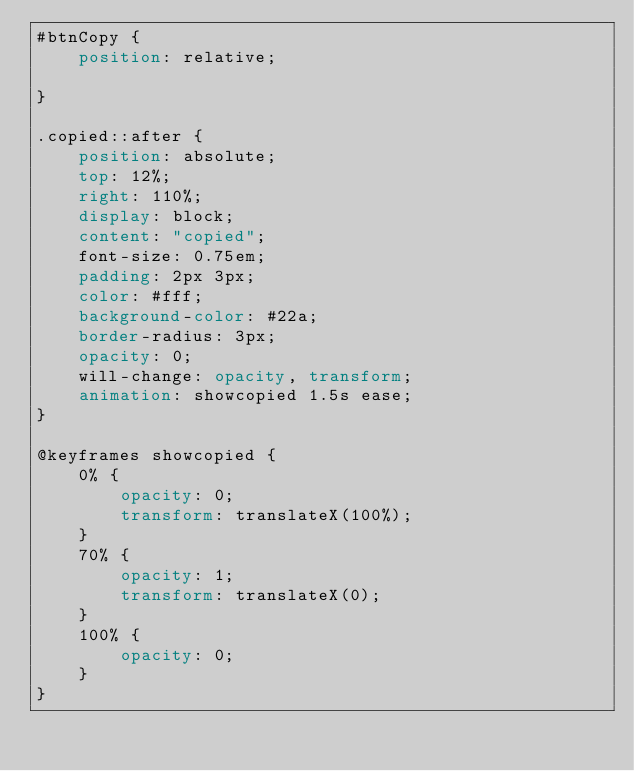Convert code to text. <code><loc_0><loc_0><loc_500><loc_500><_CSS_>#btnCopy {
    position: relative;

}

.copied::after {
    position: absolute;
    top: 12%;
    right: 110%;
    display: block;
    content: "copied";
    font-size: 0.75em;
    padding: 2px 3px;
    color: #fff;
    background-color: #22a;
    border-radius: 3px;
    opacity: 0;
    will-change: opacity, transform;
    animation: showcopied 1.5s ease;
}

@keyframes showcopied {
    0% {
        opacity: 0;
        transform: translateX(100%);
    }
    70% {
        opacity: 1;
        transform: translateX(0);
    }
    100% {
        opacity: 0;
    }
}

</code> 